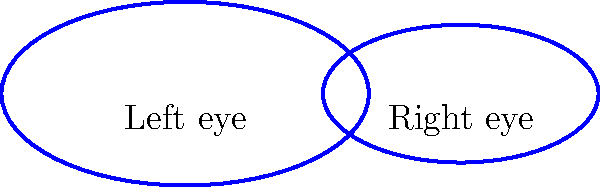In the popular anime "Big Eyes Adventure," the main character's eyes are drawn as ellipses. The left eye is represented by an ellipse with semi-major axis $a_1 = 2$ cm and semi-minor axis $b_1 = 1$ cm. The right eye is slightly smaller, with semi-major axis $a_2 = 1.5$ cm and semi-minor axis $b_2 = 0.75$ cm. Calculate the total area of both eyes in square centimeters. To solve this problem, we'll follow these steps:

1) The area of an ellipse is given by the formula: $A = \pi ab$, where $a$ is the semi-major axis and $b$ is the semi-minor axis.

2) For the left eye:
   $A_1 = \pi a_1 b_1 = \pi \cdot 2 \cdot 1 = 2\pi$ cm²

3) For the right eye:
   $A_2 = \pi a_2 b_2 = \pi \cdot 1.5 \cdot 0.75 = 1.125\pi$ cm²

4) The total area is the sum of both eyes:
   $A_{total} = A_1 + A_2 = 2\pi + 1.125\pi = 3.125\pi$ cm²

5) To get the final numerical value, we multiply by $\pi$:
   $A_{total} = 3.125 \cdot \pi \approx 9.82$ cm²

Therefore, the total area of both eyes is approximately 9.82 square centimeters.
Answer: $9.82$ cm² 